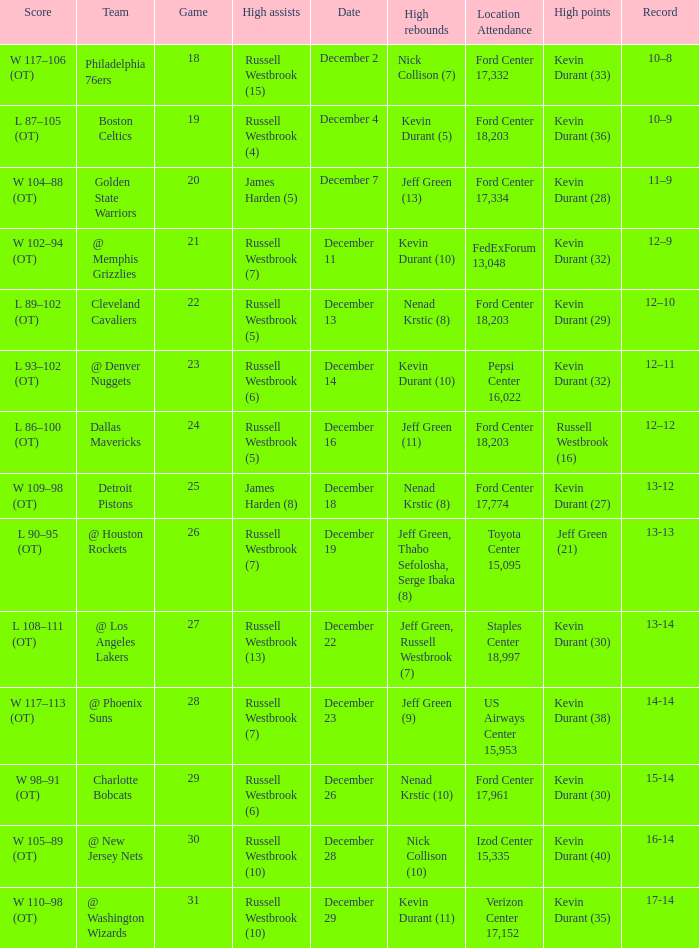I'm looking to parse the entire table for insights. Could you assist me with that? {'header': ['Score', 'Team', 'Game', 'High assists', 'Date', 'High rebounds', 'Location Attendance', 'High points', 'Record'], 'rows': [['W 117–106 (OT)', 'Philadelphia 76ers', '18', 'Russell Westbrook (15)', 'December 2', 'Nick Collison (7)', 'Ford Center 17,332', 'Kevin Durant (33)', '10–8'], ['L 87–105 (OT)', 'Boston Celtics', '19', 'Russell Westbrook (4)', 'December 4', 'Kevin Durant (5)', 'Ford Center 18,203', 'Kevin Durant (36)', '10–9'], ['W 104–88 (OT)', 'Golden State Warriors', '20', 'James Harden (5)', 'December 7', 'Jeff Green (13)', 'Ford Center 17,334', 'Kevin Durant (28)', '11–9'], ['W 102–94 (OT)', '@ Memphis Grizzlies', '21', 'Russell Westbrook (7)', 'December 11', 'Kevin Durant (10)', 'FedExForum 13,048', 'Kevin Durant (32)', '12–9'], ['L 89–102 (OT)', 'Cleveland Cavaliers', '22', 'Russell Westbrook (5)', 'December 13', 'Nenad Krstic (8)', 'Ford Center 18,203', 'Kevin Durant (29)', '12–10'], ['L 93–102 (OT)', '@ Denver Nuggets', '23', 'Russell Westbrook (6)', 'December 14', 'Kevin Durant (10)', 'Pepsi Center 16,022', 'Kevin Durant (32)', '12–11'], ['L 86–100 (OT)', 'Dallas Mavericks', '24', 'Russell Westbrook (5)', 'December 16', 'Jeff Green (11)', 'Ford Center 18,203', 'Russell Westbrook (16)', '12–12'], ['W 109–98 (OT)', 'Detroit Pistons', '25', 'James Harden (8)', 'December 18', 'Nenad Krstic (8)', 'Ford Center 17,774', 'Kevin Durant (27)', '13-12'], ['L 90–95 (OT)', '@ Houston Rockets', '26', 'Russell Westbrook (7)', 'December 19', 'Jeff Green, Thabo Sefolosha, Serge Ibaka (8)', 'Toyota Center 15,095', 'Jeff Green (21)', '13-13'], ['L 108–111 (OT)', '@ Los Angeles Lakers', '27', 'Russell Westbrook (13)', 'December 22', 'Jeff Green, Russell Westbrook (7)', 'Staples Center 18,997', 'Kevin Durant (30)', '13-14'], ['W 117–113 (OT)', '@ Phoenix Suns', '28', 'Russell Westbrook (7)', 'December 23', 'Jeff Green (9)', 'US Airways Center 15,953', 'Kevin Durant (38)', '14-14'], ['W 98–91 (OT)', 'Charlotte Bobcats', '29', 'Russell Westbrook (6)', 'December 26', 'Nenad Krstic (10)', 'Ford Center 17,961', 'Kevin Durant (30)', '15-14'], ['W 105–89 (OT)', '@ New Jersey Nets', '30', 'Russell Westbrook (10)', 'December 28', 'Nick Collison (10)', 'Izod Center 15,335', 'Kevin Durant (40)', '16-14'], ['W 110–98 (OT)', '@ Washington Wizards', '31', 'Russell Westbrook (10)', 'December 29', 'Kevin Durant (11)', 'Verizon Center 17,152', 'Kevin Durant (35)', '17-14']]} What location attendance has russell westbrook (5) as high assists and nenad krstic (8) as high rebounds? Ford Center 18,203. 